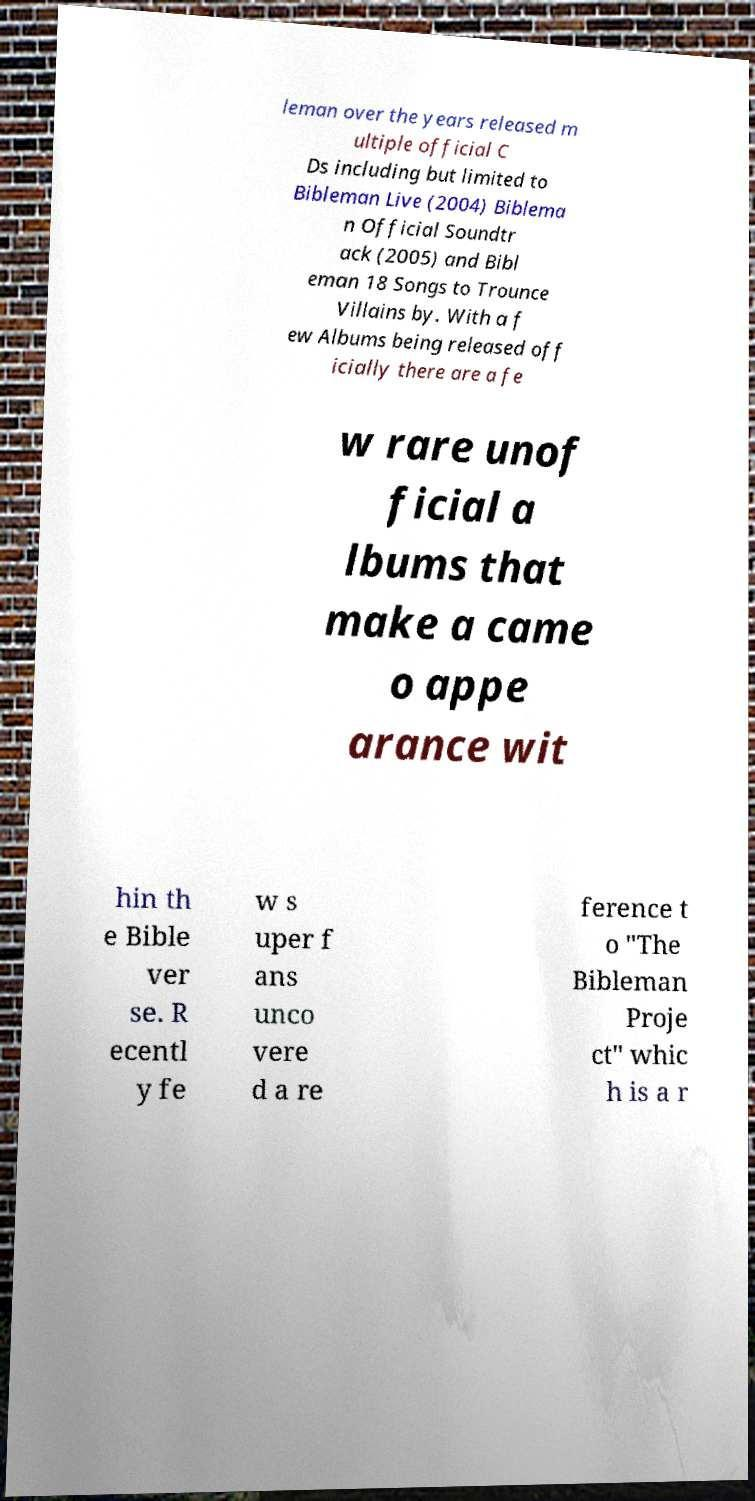There's text embedded in this image that I need extracted. Can you transcribe it verbatim? leman over the years released m ultiple official C Ds including but limited to Bibleman Live (2004) Biblema n Official Soundtr ack (2005) and Bibl eman 18 Songs to Trounce Villains by. With a f ew Albums being released off icially there are a fe w rare unof ficial a lbums that make a came o appe arance wit hin th e Bible ver se. R ecentl y fe w s uper f ans unco vere d a re ference t o "The Bibleman Proje ct" whic h is a r 